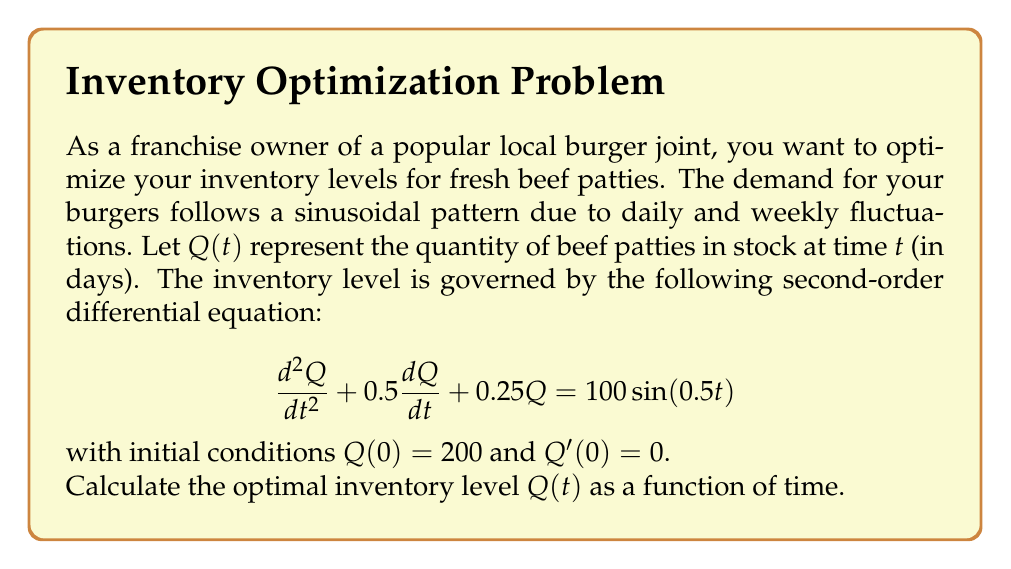Show me your answer to this math problem. To solve this second-order differential equation, we'll use the method of undetermined coefficients:

1) The characteristic equation is:
   $r^2 + 0.5r + 0.25 = 0$
   $(r + 0.25)^2 = 0$
   $r = -0.25$ (double root)

2) The complementary solution is:
   $Q_c(t) = c_1e^{-0.25t} + c_2te^{-0.25t}$

3) For the particular solution, we assume:
   $Q_p(t) = A\sin(0.5t) + B\cos(0.5t)$

4) Substitute $Q_p(t)$ into the original equation:
   $(-0.25A + 0.5B)\sin(0.5t) + (-0.25B - 0.5A)\cos(0.5t) + 0.25(A\sin(0.5t) + B\cos(0.5t)) = 100\sin(0.5t)$

5) Equating coefficients:
   $-0.25A + 0.5B + 0.25A = 100$
   $-0.25B - 0.5A + 0.25B = 0$

   Solving this system:
   $A = 160$, $B = 320$

6) The general solution is:
   $Q(t) = c_1e^{-0.25t} + c_2te^{-0.25t} + 160\sin(0.5t) + 320\cos(0.5t)$

7) Using initial conditions:
   $Q(0) = 200$: $c_1 + 320 = 200$, so $c_1 = -120$
   $Q'(0) = 0$: $-30 + c_2 + 80 = 0$, so $c_2 = -50$

8) The final solution is:
   $Q(t) = -120e^{-0.25t} - 50te^{-0.25t} + 160\sin(0.5t) + 320\cos(0.5t)$
Answer: $Q(t) = -120e^{-0.25t} - 50te^{-0.25t} + 160\sin(0.5t) + 320\cos(0.5t)$ 